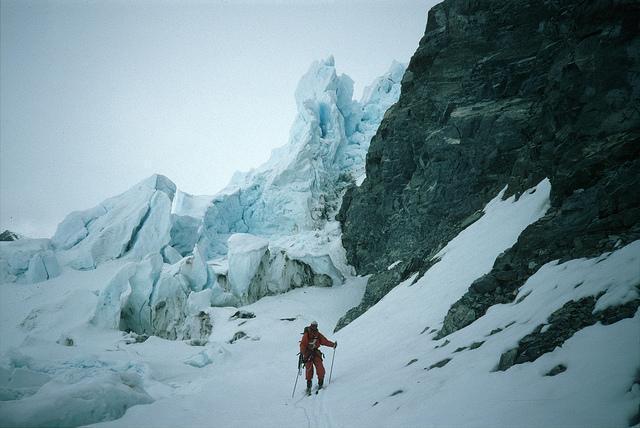How many of the sheep are babies?
Give a very brief answer. 0. 